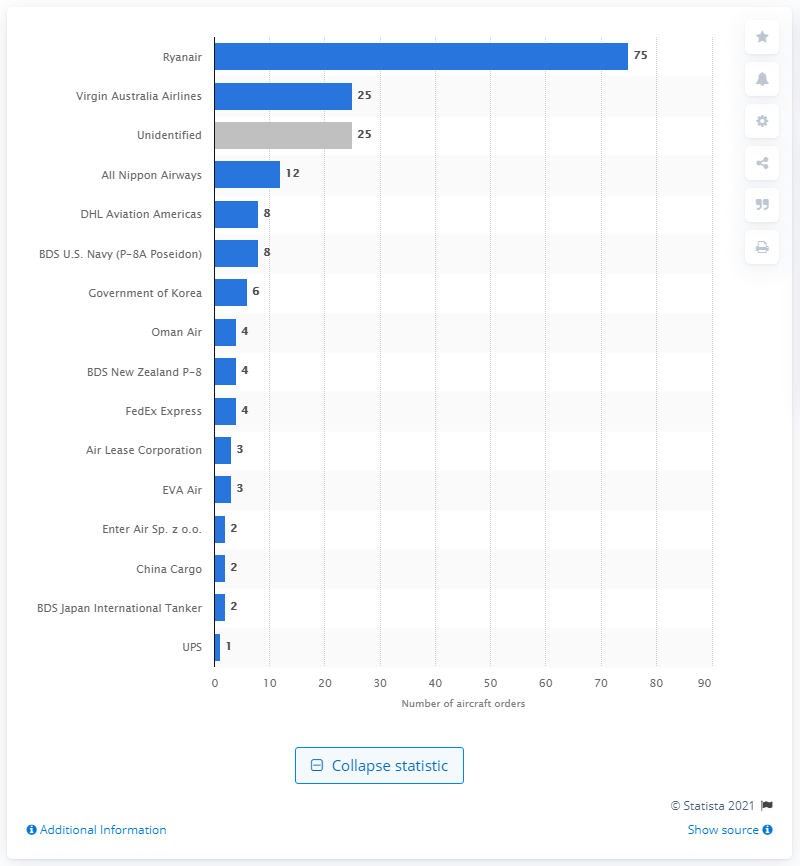Point out several critical features in this image. Boeing's largest customer in 2020 was Ryanair. 